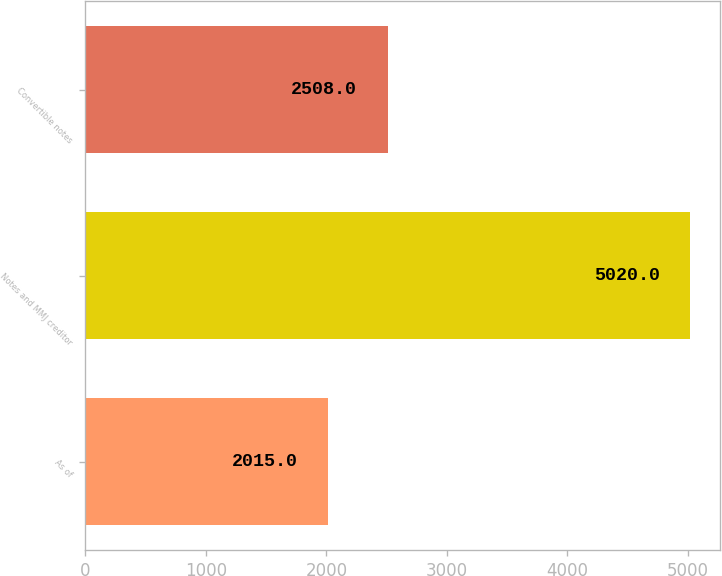<chart> <loc_0><loc_0><loc_500><loc_500><bar_chart><fcel>As of<fcel>Notes and MMJ creditor<fcel>Convertible notes<nl><fcel>2015<fcel>5020<fcel>2508<nl></chart> 